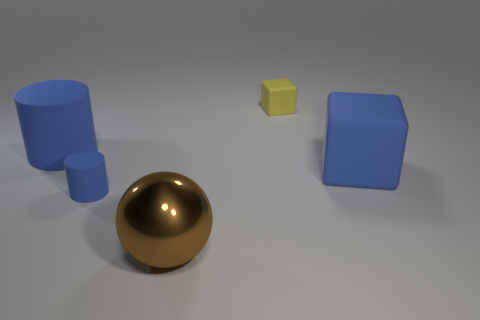Does the tiny blue thing have the same shape as the shiny object?
Give a very brief answer. No. How many small cylinders are on the left side of the tiny matte thing that is to the left of the small yellow cube?
Offer a very short reply. 0. There is a yellow object that is made of the same material as the blue block; what shape is it?
Offer a very short reply. Cube. What number of gray objects are big metal objects or big objects?
Ensure brevity in your answer.  0. Is there a large shiny thing behind the matte cylinder right of the large blue object on the left side of the large brown metal object?
Provide a succinct answer. No. Are there fewer large purple rubber cylinders than tiny yellow things?
Give a very brief answer. Yes. There is a blue thing right of the brown object; is its shape the same as the big metal object?
Make the answer very short. No. Is there a blue matte cylinder?
Ensure brevity in your answer.  Yes. What color is the rubber cylinder that is behind the cylinder in front of the big rubber cube right of the big brown thing?
Provide a succinct answer. Blue. Is the number of tiny blocks that are in front of the large brown sphere the same as the number of small blue matte objects behind the tiny blue cylinder?
Provide a short and direct response. Yes. 